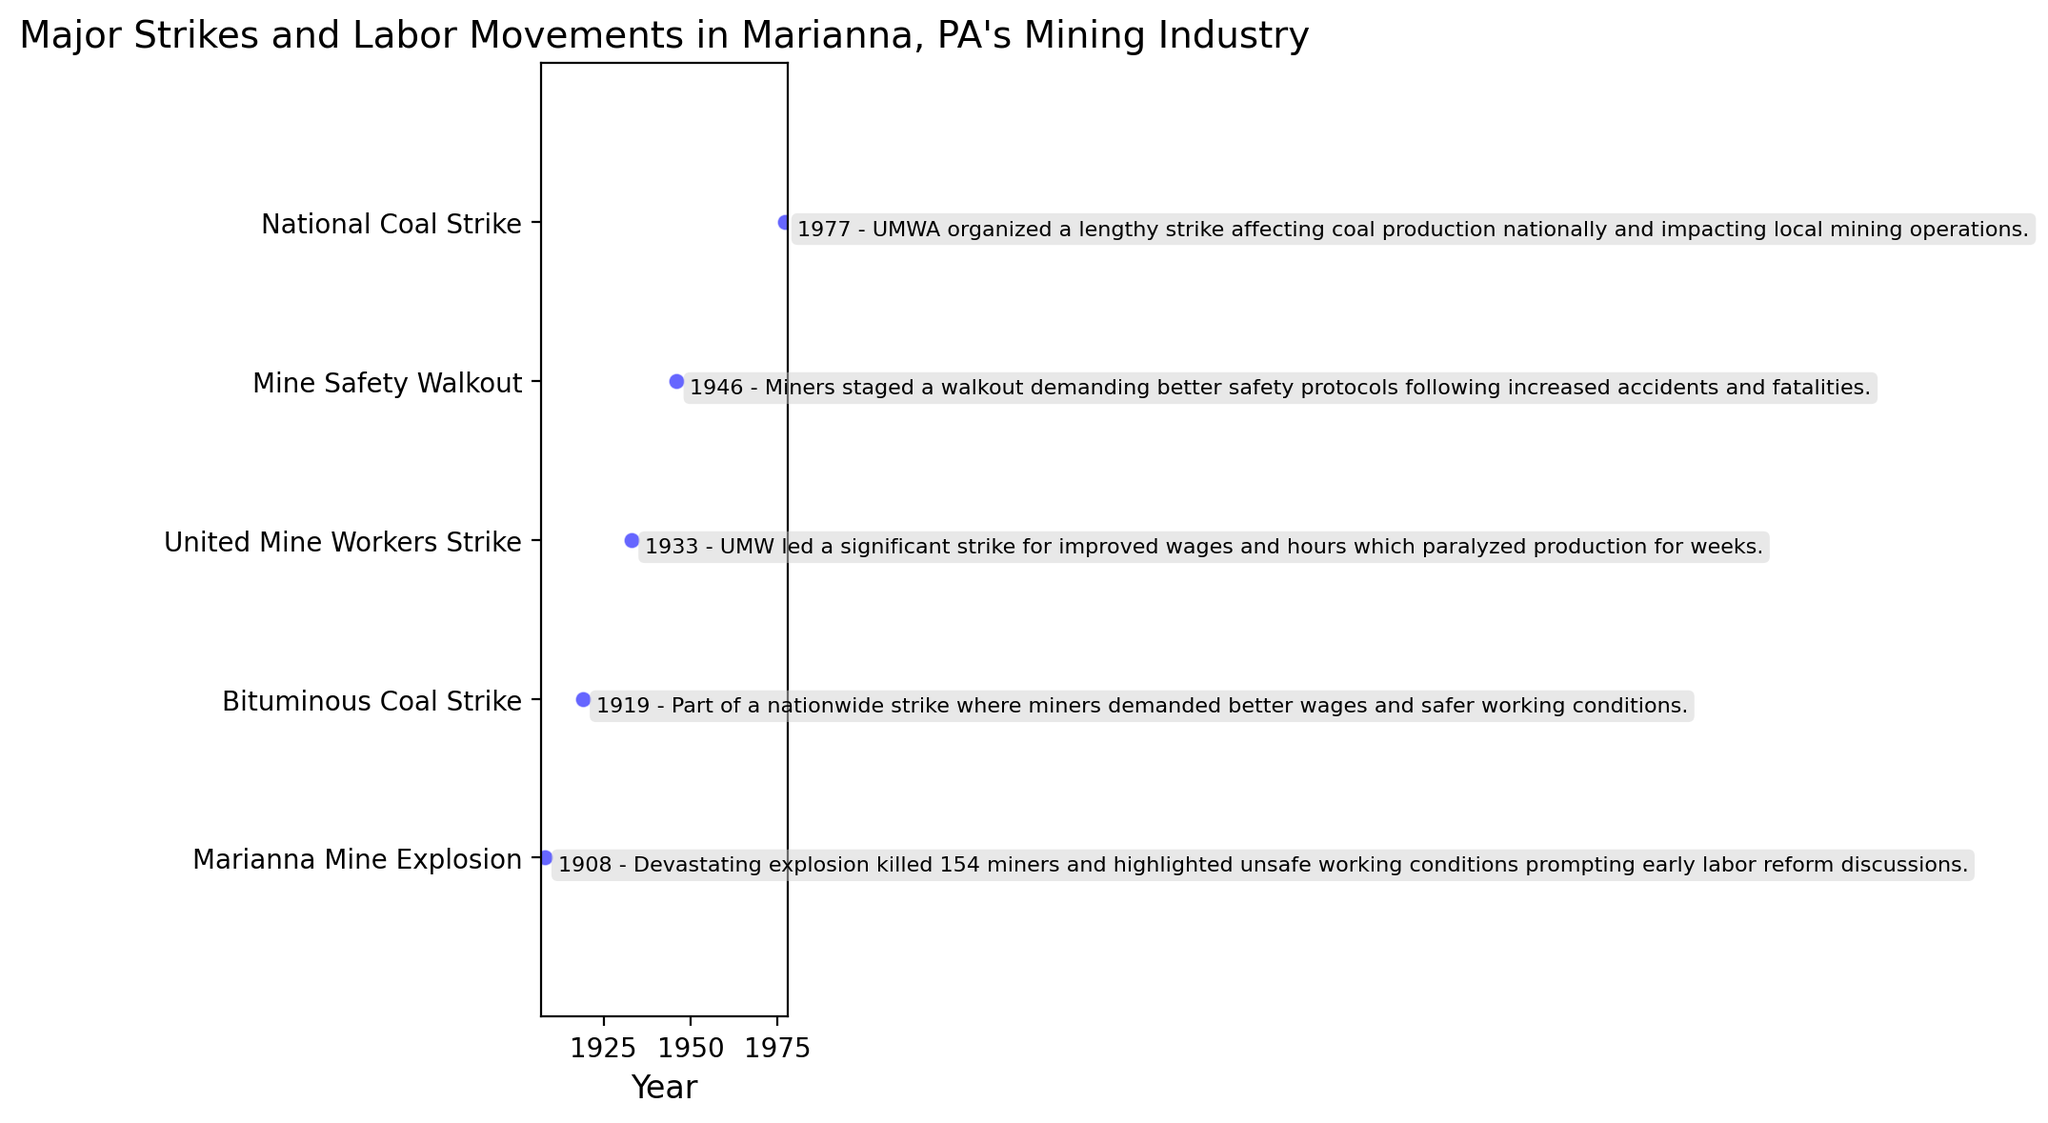What year did the Marianna Mine Explosion occur? The scatter plot shows that the Marianna Mine Explosion is annotated at the position corresponding to the year 1908.
Answer: 1908 Which strike happened right after the Bituminous Coal Strike of 1919? According to the scatter plot, the United Mine Workers Strike occurred in 1933, which is the next event after the 1919 Bituminous Coal Strike.
Answer: United Mine Workers Strike How many years passed between the United Mine Workers Strike of 1933 and the Mine Safety Walkout of 1946? To determine the number of years between these two events, subtract 1933 from 1946: 1946 - 1933 = 13 years.
Answer: 13 years Which event had the earliest occurrence according to the plot? The scatter plot shows that the Marianna Mine Explosion of 1908 occurred earliest among the listed events.
Answer: Marianna Mine Explosion How many events are plotted in total? By counting the number of y-ticks on the plot, it is evident that there are five plotted events.
Answer: 5 events Between which two events are there the fewest years? The time gap between the United Mine Workers Strike (1933) and Mine Safety Walkout (1946) is 13 years. Comparing other intervals: 11 years between the Bituminous Coal Strike (1919) and United Mine Workers Strike (1933), 8 years between the Mine Safety Walkout (1946) and National Coal Strike (1977). Thus, 8 years between 1946 and 1977 is the smallest gap.
Answer: Mine Safety Walkout and National Coal Strike Which event focused specifically on better safety protocols due to increased accidents and fatalities? The annotation for the Mine Safety Walkout of 1946 mentions a walkout demanding better safety protocols following increased accidents and fatalities.
Answer: Mine Safety Walkout What was the primary motivation behind the National Coal Strike of 1977 according to the plot? The annotation on the scatter plot for the National Coal Strike in 1977 indicates the UMWA organized a lengthy strike affecting coal production nationally and impacting local mining operations.
Answer: Affecting coal production nationally Which labor movement occurred after more than a decade since the preceding event and caused a nationwide effect? The National Coal Strike of 1977 happened 31 years after the Mine Safety Walkout of 1946 and had a national impact on coal production.
Answer: National Coal Strike How many years after the Marianna Mine Explosion did the Bituminous Coal Strike take place? The Bituminous Coal Strike occurred in 1919, and the Marianna Mine Explosion happened in 1908. Thus, the difference is 1919 - 1908 = 11 years.
Answer: 11 years 